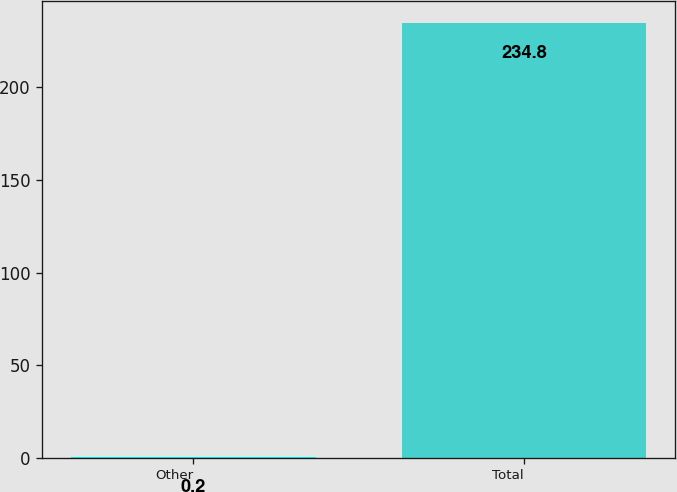<chart> <loc_0><loc_0><loc_500><loc_500><bar_chart><fcel>Other<fcel>Total<nl><fcel>0.2<fcel>234.8<nl></chart> 